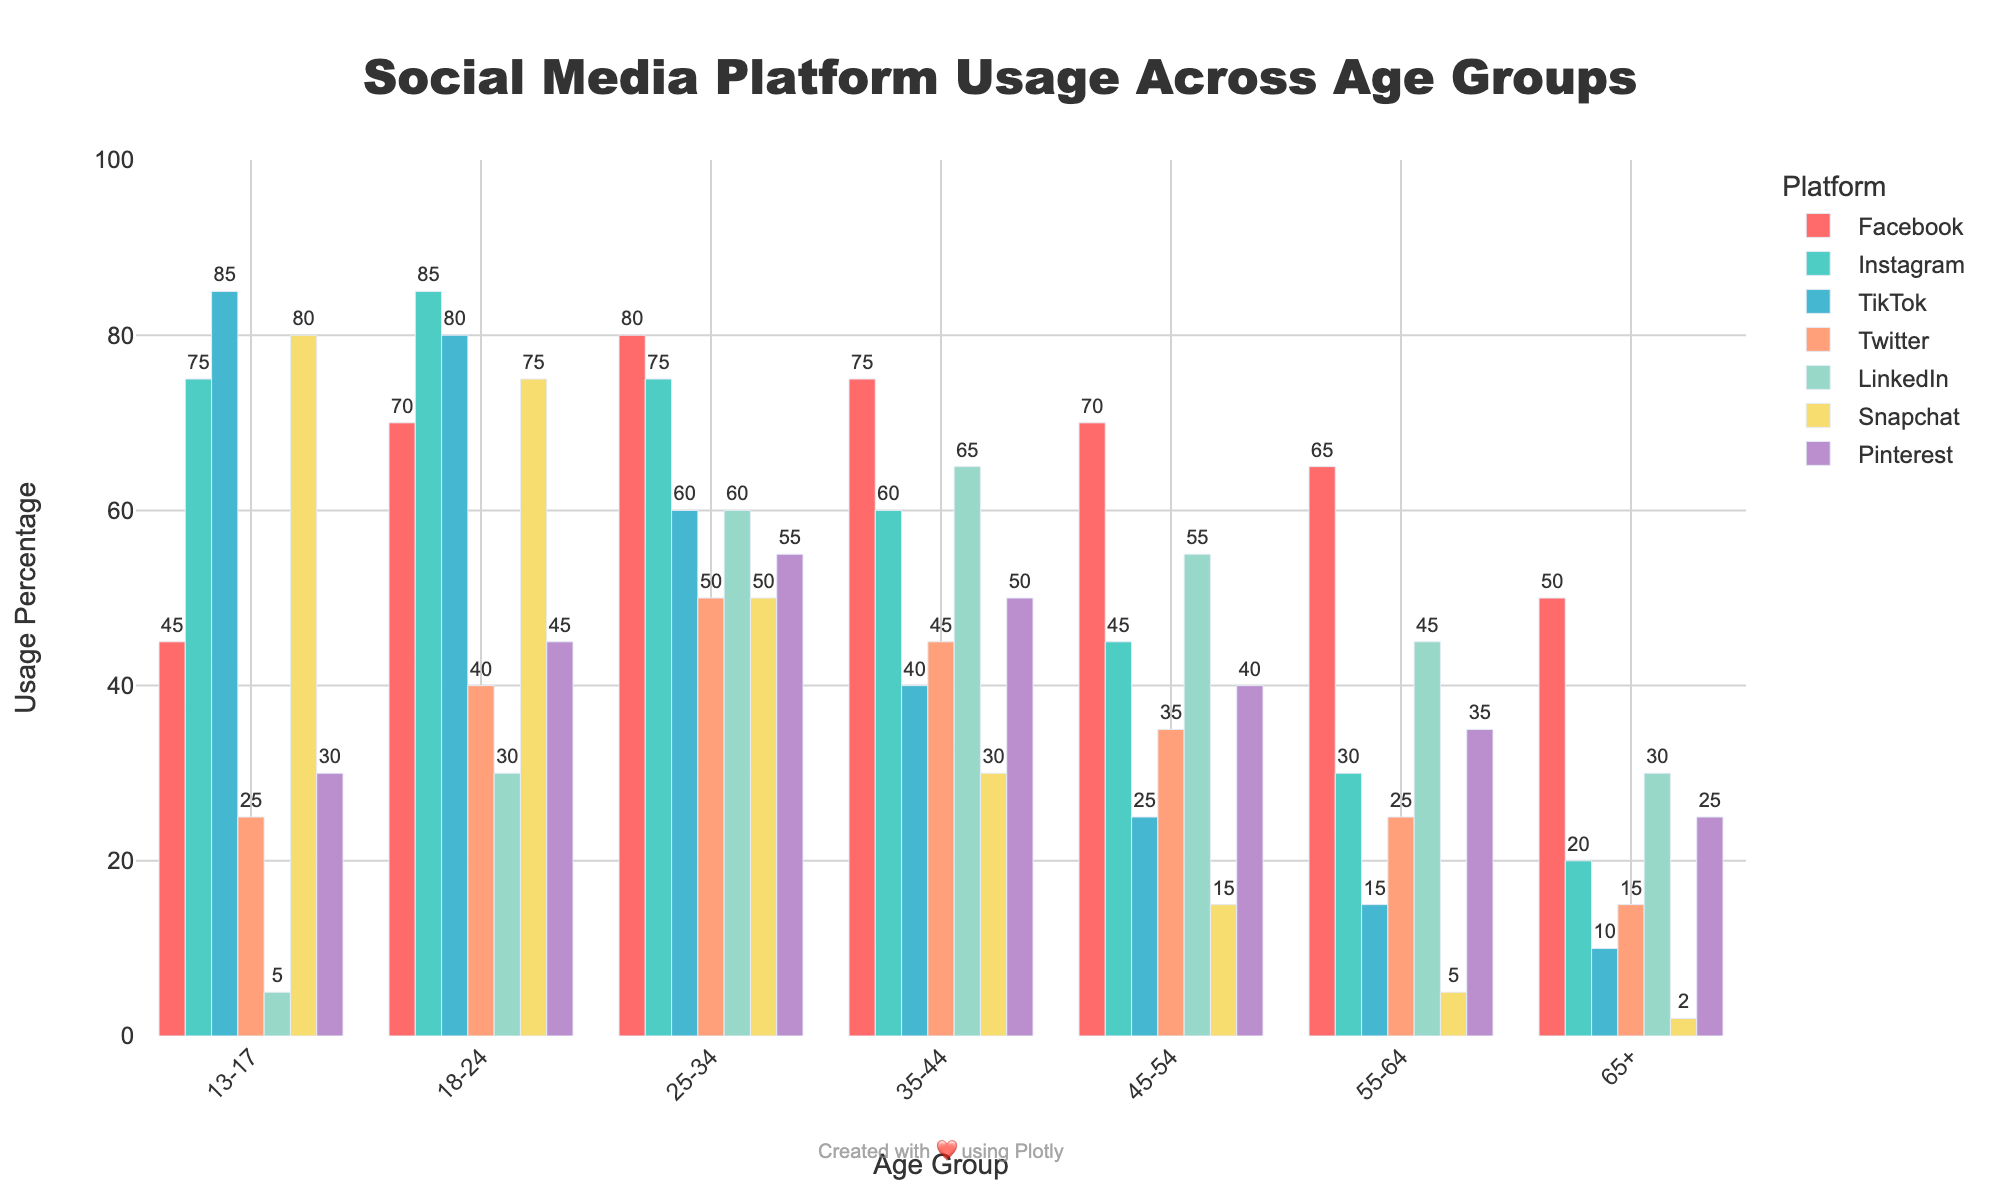What age group uses TikTok the most? To find the age group that uses TikTok the most, identify the age group with the highest percentage bar for TikTok. The highest bar for TikTok is in the 13-17 age group.
Answer: 13-17 Which platform has the lowest usage percentage among the 65+ age group? Look at the bars for the 65+ age group and find the one with the shortest height. The shortest bar corresponds to Snapchat with 2%.
Answer: Snapchat Compare the Facebook usage between the 18-24 and 25-34 age groups. Which age group has higher usage? Check the height of the Facebook bars for both the 18-24 and 25-34 age groups. The bar for 25-34 is higher than that for 18-24 (80% vs. 70%).
Answer: 25-34 What is the total usage percentage of Instagram, TikTok, and Snapchat for the 18-24 age group? Add the percentages of Instagram (85%), TikTok (80%), and Snapchat (75%) for the 18-24 age group. The total is 85 + 80 + 75 = 240%.
Answer: 240% What age group has the most diverse platform usage in terms of number of platforms above 50%? Count the number of platforms where usage is above 50% for each age group. The 18-24 age group uses five platforms above 50% (Facebook, Instagram, TikTok, Twitter, Snapchat).
Answer: 18-24 What is the difference in LinkedIn usage between the 25-34 and 45-54 age groups? Subtract the LinkedIn usage percentage for the 45-54 age group (55%) from the 25-34 age group (60%). 60% - 55% = 5%.
Answer: 5% For the 35-44 age group, which social media platforms have higher usage compared to Pinterest? Look at the 35-44 age group and compare each platform's usage to that of Pinterest (50%). Facebook (75%), Instagram (60%), Twitter (45%), LinkedIn (65%) all have higher usage than Pinterest.
Answer: Facebook, Instagram, Twitter, LinkedIn Which platform has roughly equal usage across the 25-34 and 35-44 age groups? Look for platforms where the bar heights for the 25-34 and 35-44 age groups are close in height. Pinterest has 55% for 25-34 and 50% for 35-44, which is approximately equal.
Answer: Pinterest How much higher is Snapchat usage for the 13-17 age group compared to the 55-64 age group? Subtract Snapchat usage for the 55-64 group (5%) from the 13-17 group (80%). 80% - 5% = 75%.
Answer: 75% What are the average usage percentages for all platforms across the 45-54 age group? Add the percentages for all platforms in the 45-54 age group (Facebook: 70, Instagram: 45, TikTok: 25, Twitter: 35, LinkedIn: 55, Snapchat: 15, Pinterest: 40) and then divide by 7. (70+45+25+35+55+15+40)/7 = 40.71%.
Answer: 40.71% 